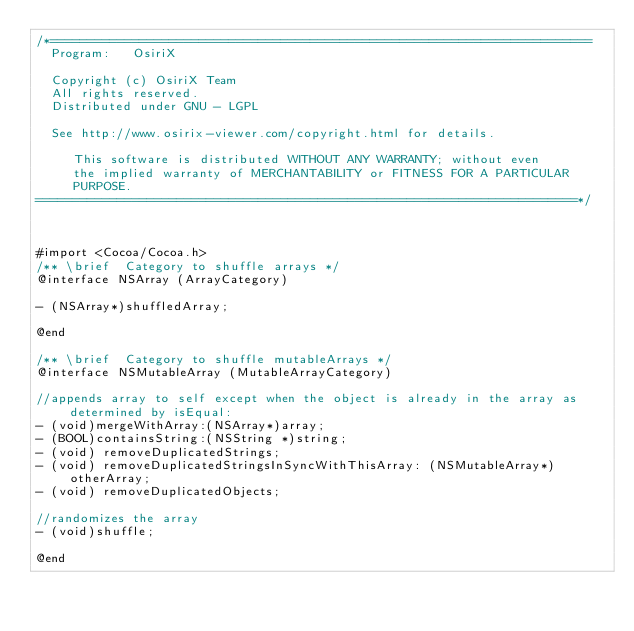<code> <loc_0><loc_0><loc_500><loc_500><_C_>/*=========================================================================
  Program:   OsiriX

  Copyright (c) OsiriX Team
  All rights reserved.
  Distributed under GNU - LGPL
  
  See http://www.osirix-viewer.com/copyright.html for details.

     This software is distributed WITHOUT ANY WARRANTY; without even
     the implied warranty of MERCHANTABILITY or FITNESS FOR A PARTICULAR
     PURPOSE.
=========================================================================*/



#import <Cocoa/Cocoa.h>
/** \brief  Category to shuffle arrays */
@interface NSArray (ArrayCategory)

- (NSArray*)shuffledArray;

@end

/** \brief  Category to shuffle mutableArrays */
@interface NSMutableArray (MutableArrayCategory)

//appends array to self except when the object is already in the array as determined by isEqual:
- (void)mergeWithArray:(NSArray*)array;
- (BOOL)containsString:(NSString *)string;
- (void) removeDuplicatedStrings;
- (void) removeDuplicatedStringsInSyncWithThisArray: (NSMutableArray*) otherArray;
- (void) removeDuplicatedObjects;

//randomizes the array
- (void)shuffle;

@end
</code> 